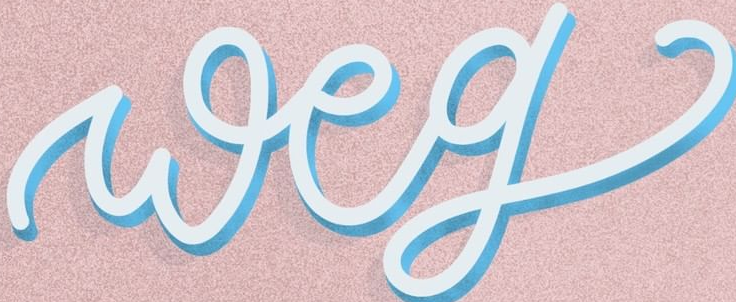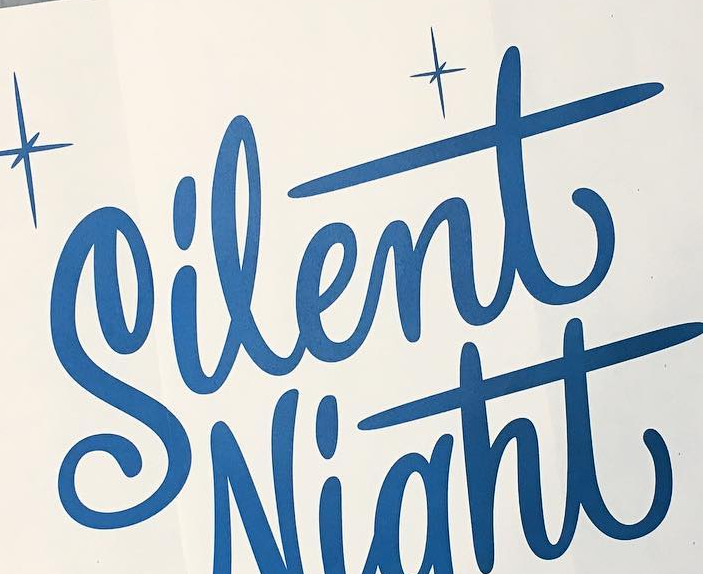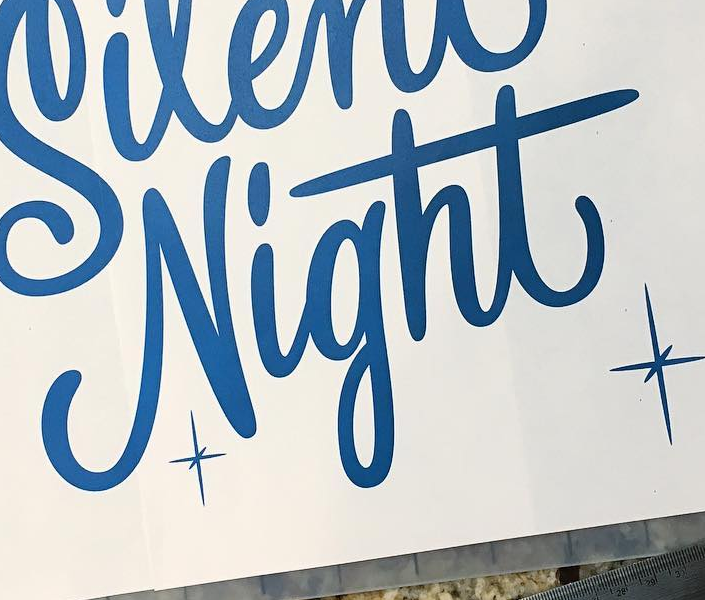What text is displayed in these images sequentially, separated by a semicolon? weg; Silent; Night 